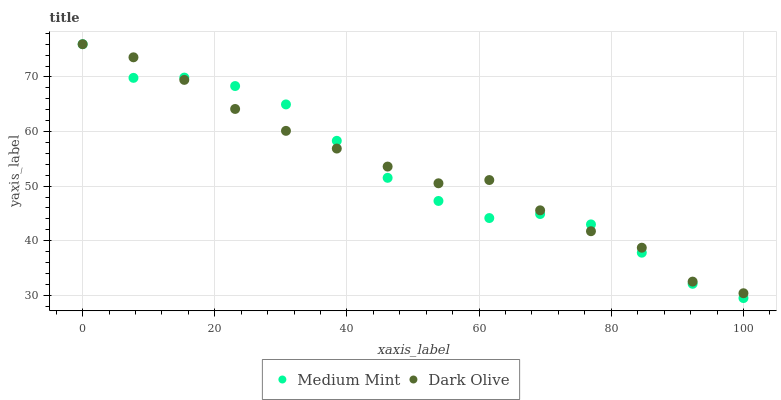Does Medium Mint have the minimum area under the curve?
Answer yes or no. Yes. Does Dark Olive have the maximum area under the curve?
Answer yes or no. Yes. Does Dark Olive have the minimum area under the curve?
Answer yes or no. No. Is Dark Olive the smoothest?
Answer yes or no. Yes. Is Medium Mint the roughest?
Answer yes or no. Yes. Is Dark Olive the roughest?
Answer yes or no. No. Does Medium Mint have the lowest value?
Answer yes or no. Yes. Does Dark Olive have the lowest value?
Answer yes or no. No. Does Dark Olive have the highest value?
Answer yes or no. Yes. Does Medium Mint intersect Dark Olive?
Answer yes or no. Yes. Is Medium Mint less than Dark Olive?
Answer yes or no. No. Is Medium Mint greater than Dark Olive?
Answer yes or no. No. 